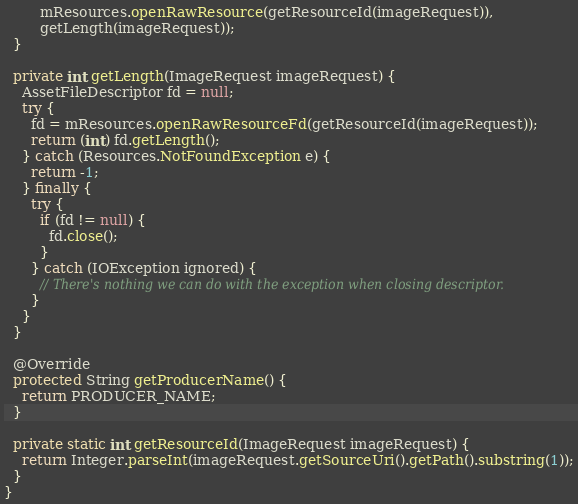Convert code to text. <code><loc_0><loc_0><loc_500><loc_500><_Java_>        mResources.openRawResource(getResourceId(imageRequest)),
        getLength(imageRequest));
  }

  private int getLength(ImageRequest imageRequest) {
    AssetFileDescriptor fd = null;
    try {
      fd = mResources.openRawResourceFd(getResourceId(imageRequest));
      return (int) fd.getLength();
    } catch (Resources.NotFoundException e) {
      return -1;
    } finally {
      try {
        if (fd != null) {
          fd.close();
        }
      } catch (IOException ignored) {
        // There's nothing we can do with the exception when closing descriptor.
      }
    }
  }

  @Override
  protected String getProducerName() {
    return PRODUCER_NAME;
  }

  private static int getResourceId(ImageRequest imageRequest) {
    return Integer.parseInt(imageRequest.getSourceUri().getPath().substring(1));
  }
}
</code> 